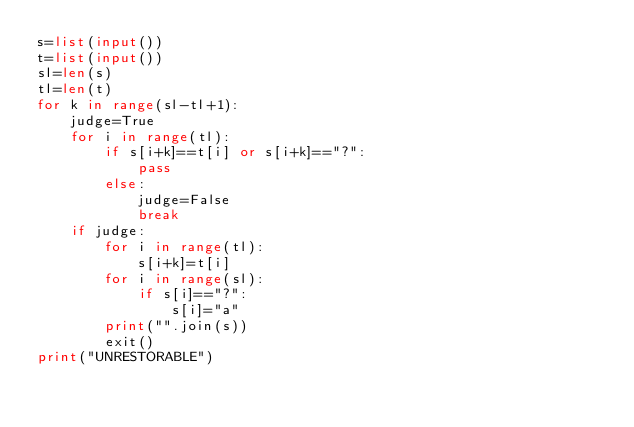<code> <loc_0><loc_0><loc_500><loc_500><_Python_>s=list(input())
t=list(input())
sl=len(s)
tl=len(t)
for k in range(sl-tl+1):
    judge=True
    for i in range(tl):
        if s[i+k]==t[i] or s[i+k]=="?":
            pass
        else:
            judge=False
            break
    if judge:
        for i in range(tl):
            s[i+k]=t[i]
        for i in range(sl):
            if s[i]=="?":
                s[i]="a"
        print("".join(s))
        exit()
print("UNRESTORABLE")
</code> 